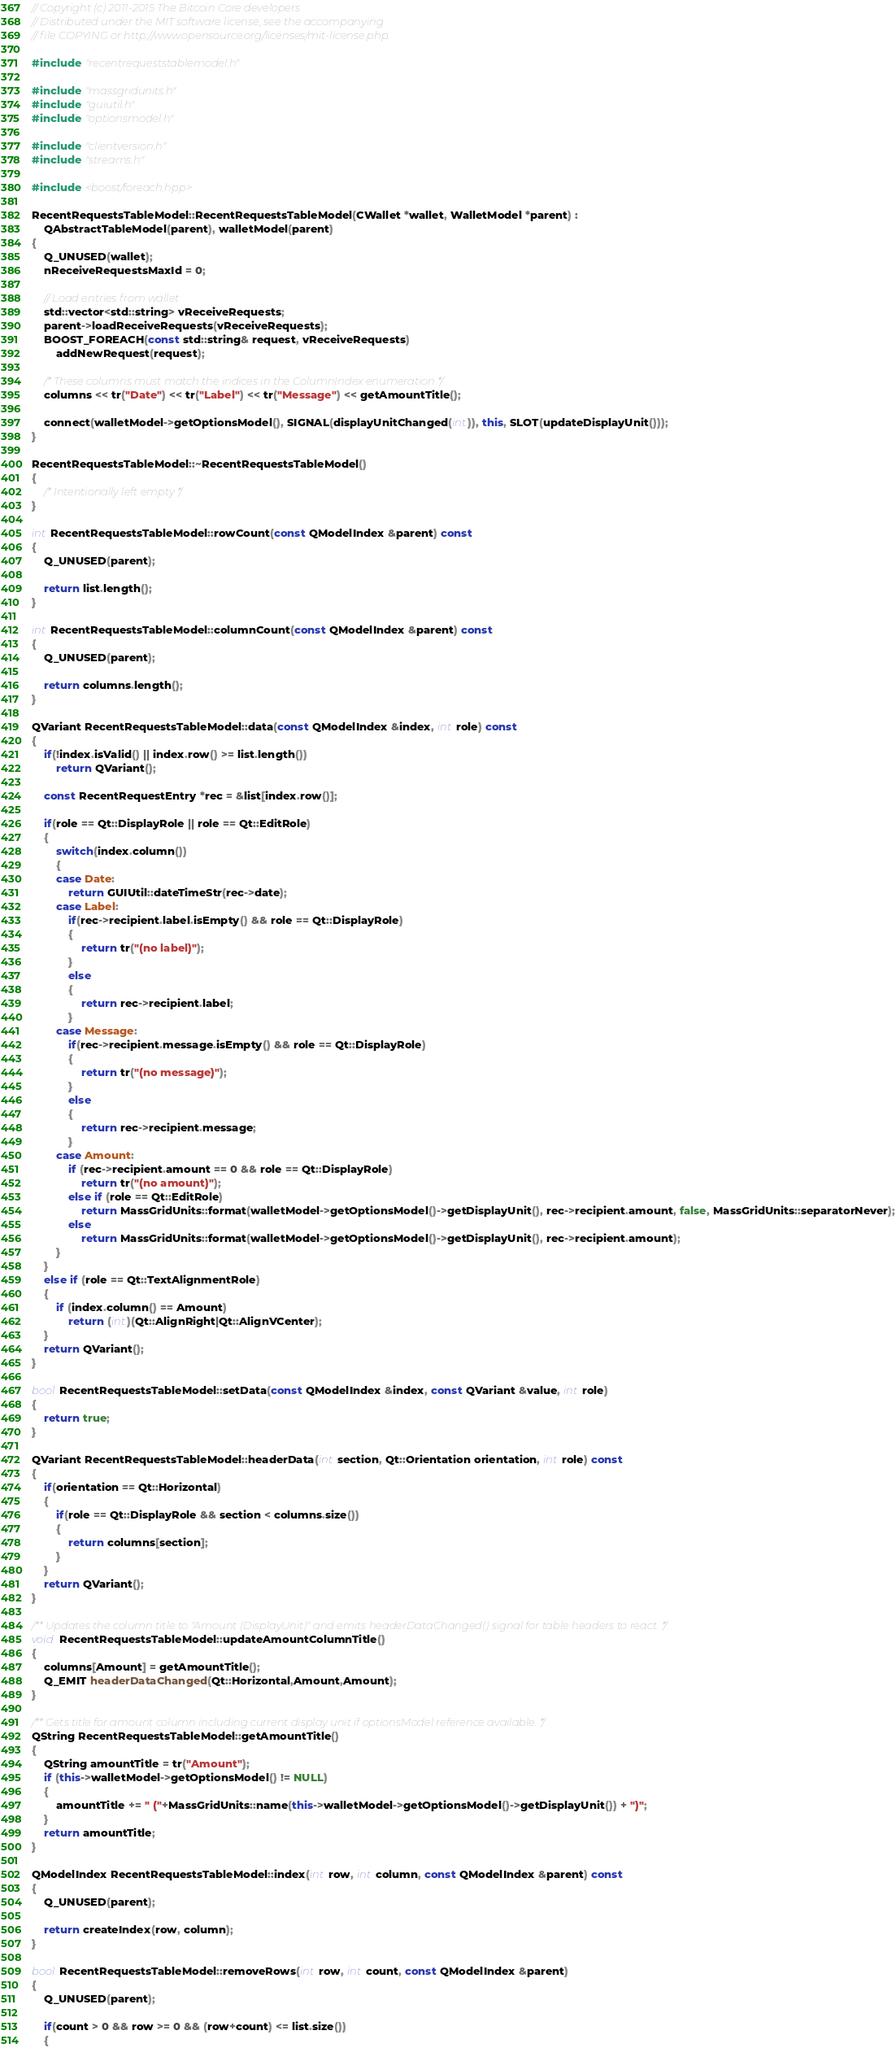<code> <loc_0><loc_0><loc_500><loc_500><_C++_>// Copyright (c) 2011-2015 The Bitcoin Core developers
// Distributed under the MIT software license, see the accompanying
// file COPYING or http://www.opensource.org/licenses/mit-license.php.

#include "recentrequeststablemodel.h"

#include "massgridunits.h"
#include "guiutil.h"
#include "optionsmodel.h"

#include "clientversion.h"
#include "streams.h"

#include <boost/foreach.hpp>

RecentRequestsTableModel::RecentRequestsTableModel(CWallet *wallet, WalletModel *parent) :
    QAbstractTableModel(parent), walletModel(parent)
{
    Q_UNUSED(wallet);
    nReceiveRequestsMaxId = 0;

    // Load entries from wallet
    std::vector<std::string> vReceiveRequests;
    parent->loadReceiveRequests(vReceiveRequests);
    BOOST_FOREACH(const std::string& request, vReceiveRequests)
        addNewRequest(request);

    /* These columns must match the indices in the ColumnIndex enumeration */
    columns << tr("Date") << tr("Label") << tr("Message") << getAmountTitle();

    connect(walletModel->getOptionsModel(), SIGNAL(displayUnitChanged(int)), this, SLOT(updateDisplayUnit()));
}

RecentRequestsTableModel::~RecentRequestsTableModel()
{
    /* Intentionally left empty */
}

int RecentRequestsTableModel::rowCount(const QModelIndex &parent) const
{
    Q_UNUSED(parent);

    return list.length();
}

int RecentRequestsTableModel::columnCount(const QModelIndex &parent) const
{
    Q_UNUSED(parent);

    return columns.length();
}

QVariant RecentRequestsTableModel::data(const QModelIndex &index, int role) const
{
    if(!index.isValid() || index.row() >= list.length())
        return QVariant();

    const RecentRequestEntry *rec = &list[index.row()];

    if(role == Qt::DisplayRole || role == Qt::EditRole)
    {
        switch(index.column())
        {
        case Date:
            return GUIUtil::dateTimeStr(rec->date);
        case Label:
            if(rec->recipient.label.isEmpty() && role == Qt::DisplayRole)
            {
                return tr("(no label)");
            }
            else
            {
                return rec->recipient.label;
            }
        case Message:
            if(rec->recipient.message.isEmpty() && role == Qt::DisplayRole)
            {
                return tr("(no message)");
            }
            else
            {
                return rec->recipient.message;
            }
        case Amount:
            if (rec->recipient.amount == 0 && role == Qt::DisplayRole)
                return tr("(no amount)");
            else if (role == Qt::EditRole)
                return MassGridUnits::format(walletModel->getOptionsModel()->getDisplayUnit(), rec->recipient.amount, false, MassGridUnits::separatorNever);
            else
                return MassGridUnits::format(walletModel->getOptionsModel()->getDisplayUnit(), rec->recipient.amount);
        }
    }
    else if (role == Qt::TextAlignmentRole)
    {
        if (index.column() == Amount)
            return (int)(Qt::AlignRight|Qt::AlignVCenter);
    }
    return QVariant();
}

bool RecentRequestsTableModel::setData(const QModelIndex &index, const QVariant &value, int role)
{
    return true;
}

QVariant RecentRequestsTableModel::headerData(int section, Qt::Orientation orientation, int role) const
{
    if(orientation == Qt::Horizontal)
    {
        if(role == Qt::DisplayRole && section < columns.size())
        {
            return columns[section];
        }
    }
    return QVariant();
}

/** Updates the column title to "Amount (DisplayUnit)" and emits headerDataChanged() signal for table headers to react. */
void RecentRequestsTableModel::updateAmountColumnTitle()
{
    columns[Amount] = getAmountTitle();
    Q_EMIT headerDataChanged(Qt::Horizontal,Amount,Amount);
}

/** Gets title for amount column including current display unit if optionsModel reference available. */
QString RecentRequestsTableModel::getAmountTitle()
{
    QString amountTitle = tr("Amount");
    if (this->walletModel->getOptionsModel() != NULL)
    {
        amountTitle += " ("+MassGridUnits::name(this->walletModel->getOptionsModel()->getDisplayUnit()) + ")";
    }
    return amountTitle;
}

QModelIndex RecentRequestsTableModel::index(int row, int column, const QModelIndex &parent) const
{
    Q_UNUSED(parent);

    return createIndex(row, column);
}

bool RecentRequestsTableModel::removeRows(int row, int count, const QModelIndex &parent)
{
    Q_UNUSED(parent);

    if(count > 0 && row >= 0 && (row+count) <= list.size())
    {</code> 